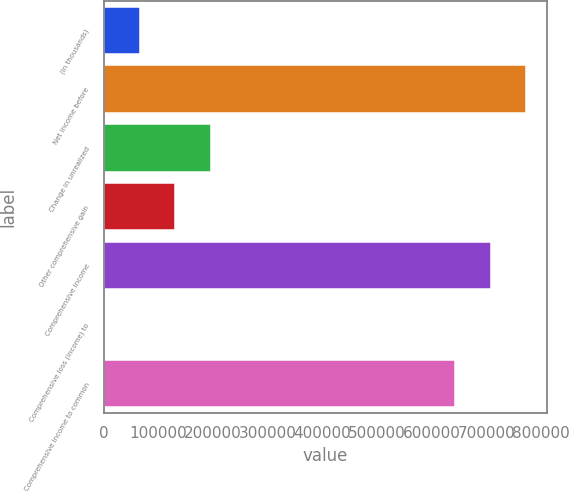Convert chart to OTSL. <chart><loc_0><loc_0><loc_500><loc_500><bar_chart><fcel>(In thousands)<fcel>Net income before<fcel>Change in unrealized<fcel>Other comprehensive gain<fcel>Comprehensive income<fcel>Comprehensive loss (income) to<fcel>Comprehensive income to common<nl><fcel>65637.1<fcel>772813<fcel>195407<fcel>130522<fcel>707928<fcel>752<fcel>643043<nl></chart> 